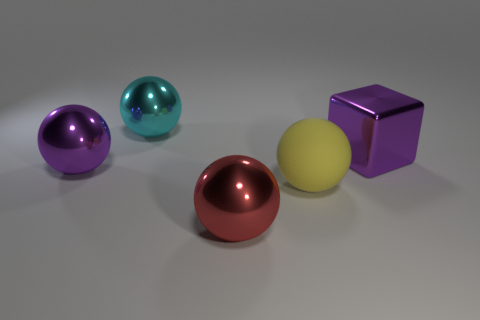How many other objects are the same material as the large block? Three objects share the same glossy and smooth material characteristics as the large purple block. These objects are the red, blue, and purple spheres, all exhibiting reflections and highlights indicative of their similar material properties. 